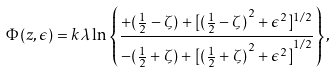<formula> <loc_0><loc_0><loc_500><loc_500>\Phi ( z , \epsilon ) = k \lambda \ln \left \{ \frac { + ( \frac { 1 } { 2 } - \zeta ) + [ { ( \frac { 1 } { 2 } - \zeta ) } ^ { 2 } + { \epsilon } ^ { 2 } ] ^ { 1 / 2 } } { - ( \frac { 1 } { 2 } + \zeta ) + { [ { ( \frac { 1 } { 2 } + \zeta ) } ^ { 2 } + { \epsilon } ^ { 2 } ] } ^ { 1 / 2 } } \right \} ,</formula> 